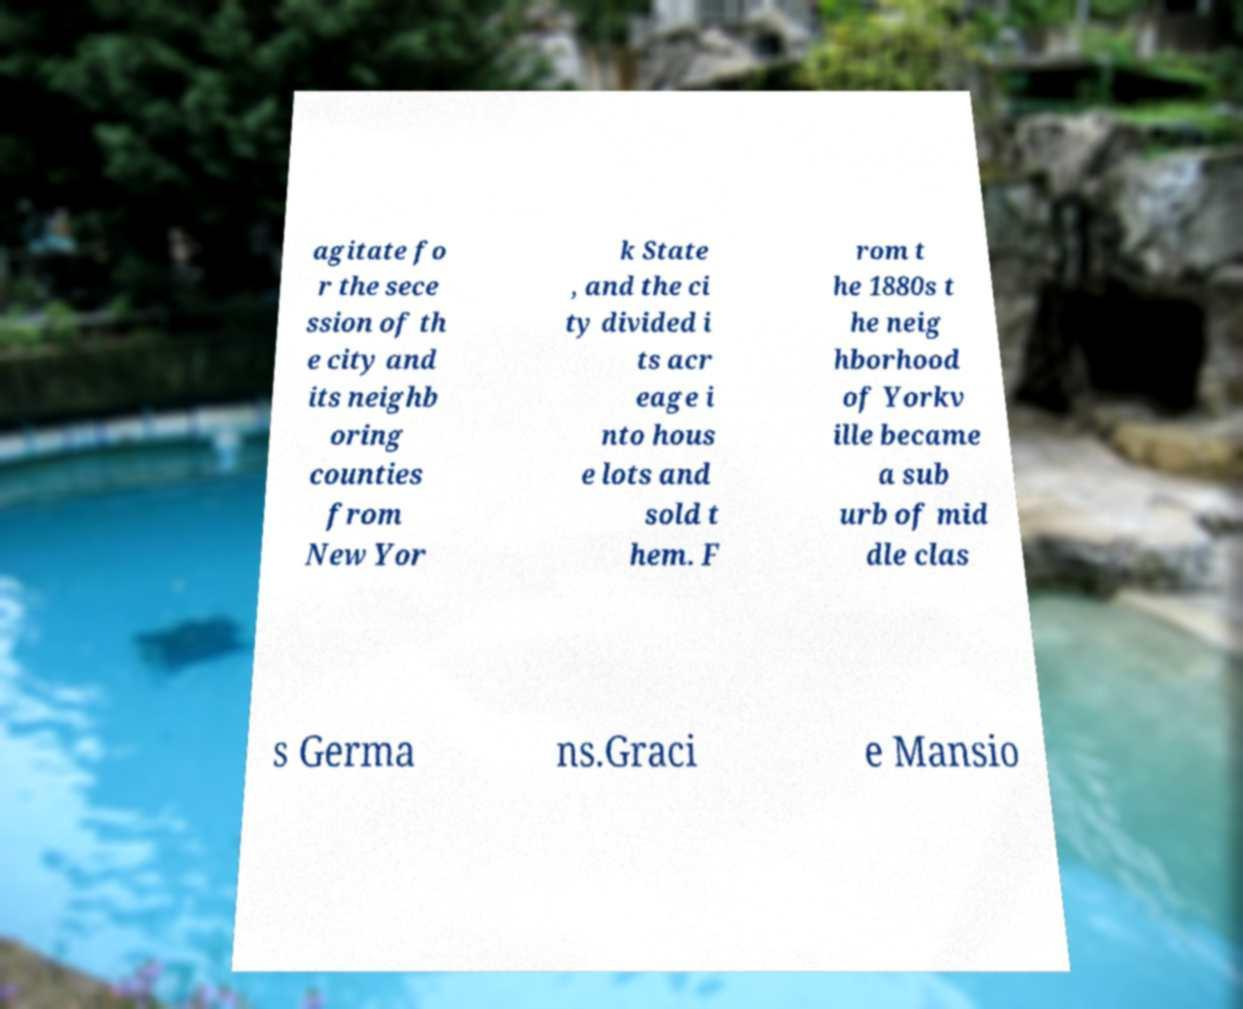I need the written content from this picture converted into text. Can you do that? agitate fo r the sece ssion of th e city and its neighb oring counties from New Yor k State , and the ci ty divided i ts acr eage i nto hous e lots and sold t hem. F rom t he 1880s t he neig hborhood of Yorkv ille became a sub urb of mid dle clas s Germa ns.Graci e Mansio 